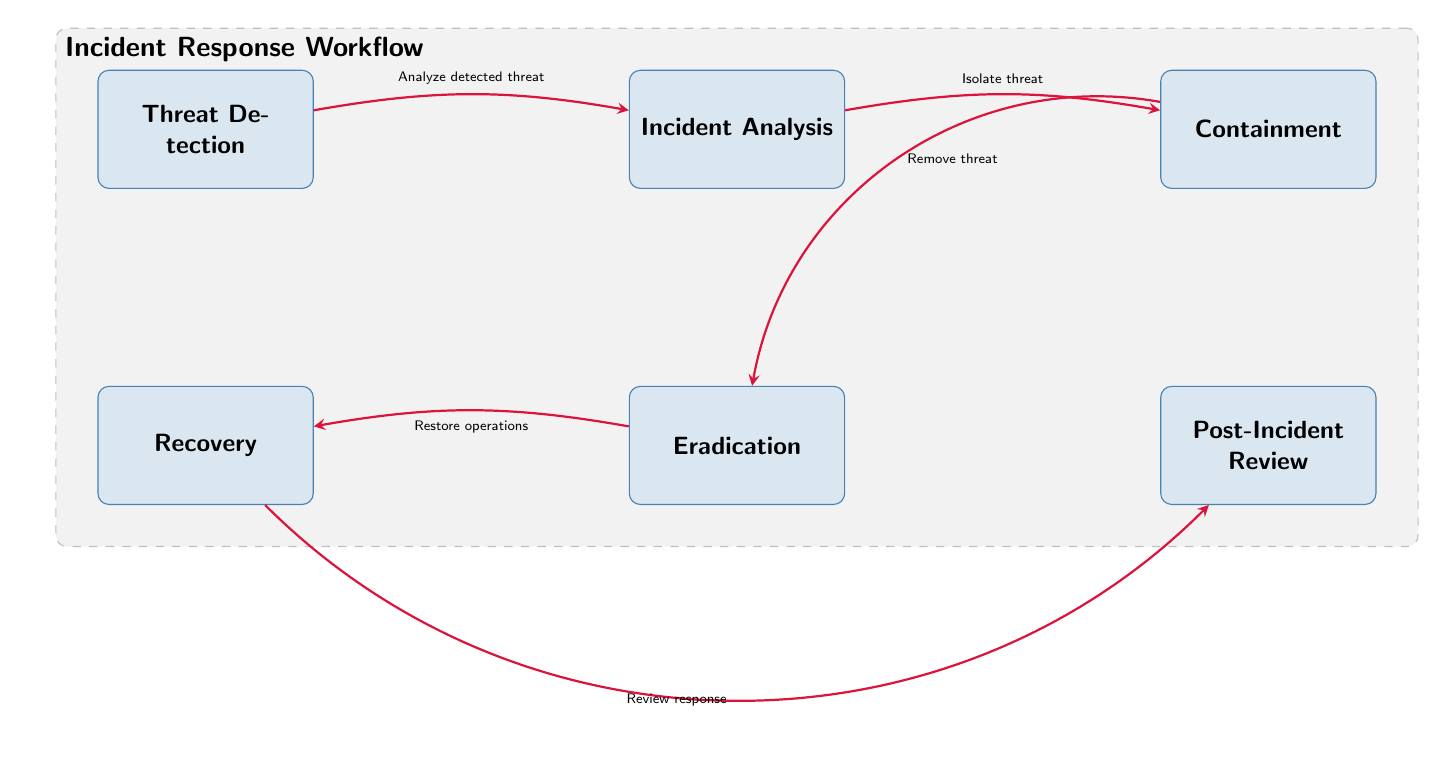What are the stages in the incident response workflow? The incident response workflow features the stages: Threat Detection, Incident Analysis, Containment, Eradication, Recovery, and Post-Incident Review. This information is displayed directly in the diagram as labeled nodes.
Answer: Threat Detection, Incident Analysis, Containment, Eradication, Recovery, Post-Incident Review What does the arrow from Threat Detection to Incident Analysis indicate? The arrow indicates the flow of the incident response process, specifically that after detecting a threat, the next step is Incident Analysis. This shows the logical sequence of actions in the workflow.
Answer: Analyze detected threat How many edges are present in the diagram? By counting the arrows connecting the nodes, there are a total of 5 edges present in the diagram. This count reflects the transitions between each stage of the incident response workflow.
Answer: 5 Which two stages are connected by the arrow labeled "Isolate threat"? The "Isolate threat" arrow connects the stages of Incident Analysis and Containment. This indicates the action to take after analyzing a threat, leading to the containment of that threat.
Answer: Incident Analysis and Containment In what order do the stages proceed from initial detection to recovery? The order of the stages is: Threat Detection, Incident Analysis, Containment, Eradication, Recovery, and finally Post-Incident Review. This sequence outlines the systematic approach to responding to cybersecurity incidents, as represented in the diagram.
Answer: Threat Detection, Incident Analysis, Containment, Eradication, Recovery, Post-Incident Review What is the final stage that follows Recovery? The final stage that follows Recovery is Post-Incident Review. This is where the organization reviews the response to improve future processes, as indicated by the layout of the diagram.
Answer: Post-Incident Review What action follows Eradication, according to the diagram? According to the diagram, the action that follows Eradication is Recovery, which involves restoring operations after the threat has been removed. This is clearly shown by the arrow connecting these two nodes.
Answer: Restore operations What does the background layer in the diagram signify? The background layer, outlined by a dashed box, signifies the overall framework of the incident response workflow, visually encapsulating all stages and the relationships between them. This helps to highlight the comprehensive process of responding to incidents.
Answer: Overall framework What is the primary purpose of the Incident Response Workflow diagram? The primary purpose of the Incident Response Workflow diagram is to communicate the organized process that the agency follows to effectively respond to cybersecurity incidents. It visually represents each step and relationship to enhance understanding and compliance.
Answer: Communicate organized process 